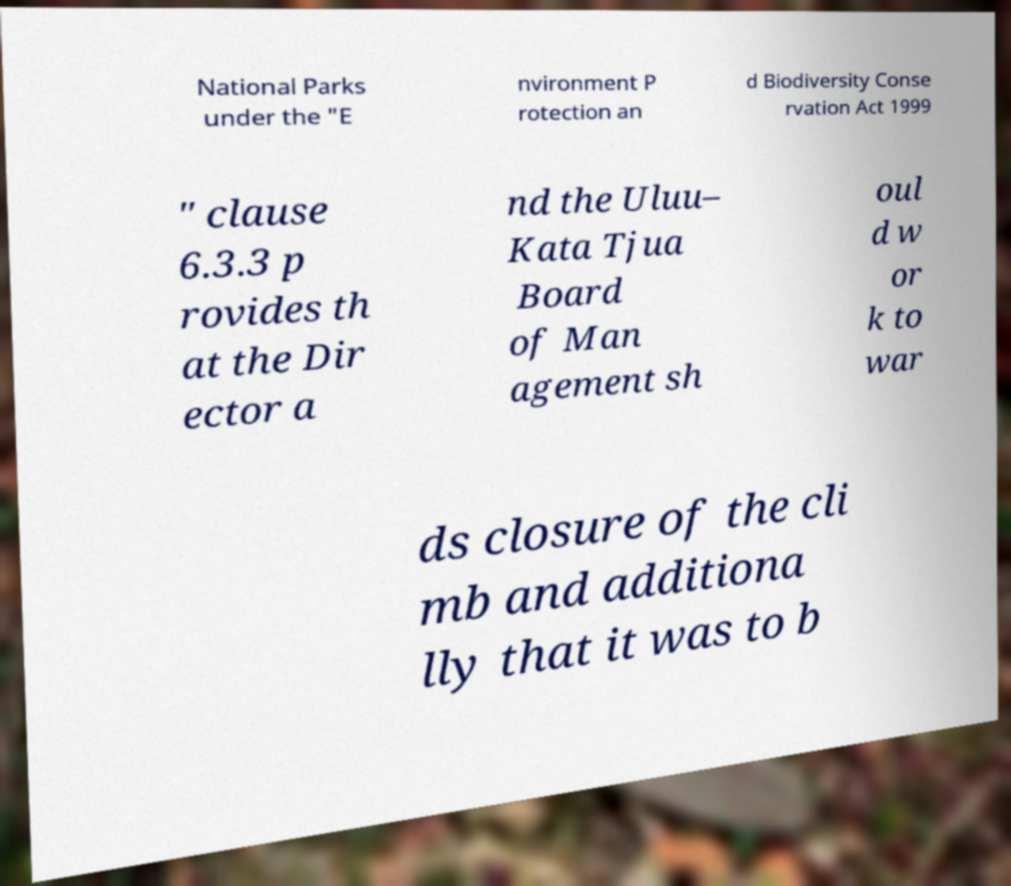There's text embedded in this image that I need extracted. Can you transcribe it verbatim? National Parks under the "E nvironment P rotection an d Biodiversity Conse rvation Act 1999 " clause 6.3.3 p rovides th at the Dir ector a nd the Uluu– Kata Tjua Board of Man agement sh oul d w or k to war ds closure of the cli mb and additiona lly that it was to b 